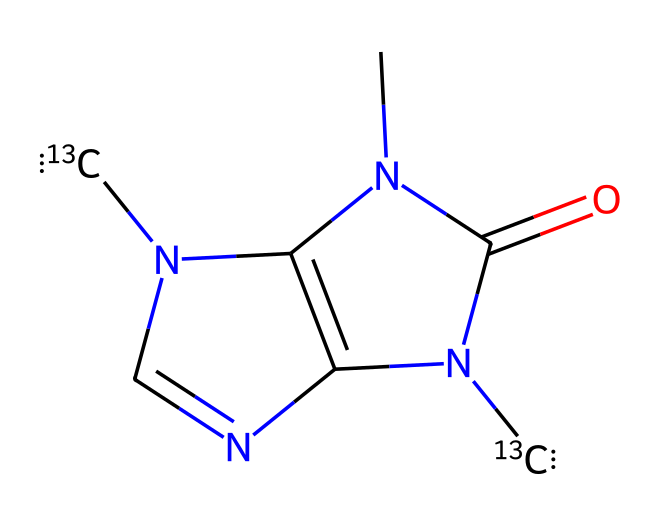What is the main chemical compound represented by the SMILES? The SMILES represents caffeine, which is recognized by its nitrogen and carbon structure typical for methylxanthines.
Answer: caffeine How many nitrogen atoms are present in the structure? By inspecting the SMILES, there are four nitrogen atoms indicated; each "N" represents one nitrogen atom.
Answer: four What is the total number of carbon atoms in the structure? The structure contains eight carbon atoms, as each "[13C]" and "C" contributes one carbon to the count regardless of isotope.
Answer: eight What role do isotopes play in this caffeine structure? The presence of [13C] indicates that there are two carbon-13 isotopes in the caffeine molecule, which affects its mass and can influence metabolic processes differently than standard carbon.
Answer: isotopes affect mass How does the presence of [13C] isotopes influence the biological effects of caffeine? The [13C] isotopes might not change the biological function of caffeine significantly, but they can alter the tracing in metabolic studies and affect the rate of metabolism in experiments.
Answer: tracing in studies What type of functional group is present in caffeine? Caffeine has a carbonyl group and nitrogen atoms, which form amide and heterocyclic structures typical for its class of compounds.
Answer: carbonyl group What can be inferred about the energy drinks containing caffeine based on this structure? The presence of caffeine, a stimulant, suggests that energy drinks provide increased alertness and energy due to the structure influencing the nervous system's response.
Answer: stimulant 